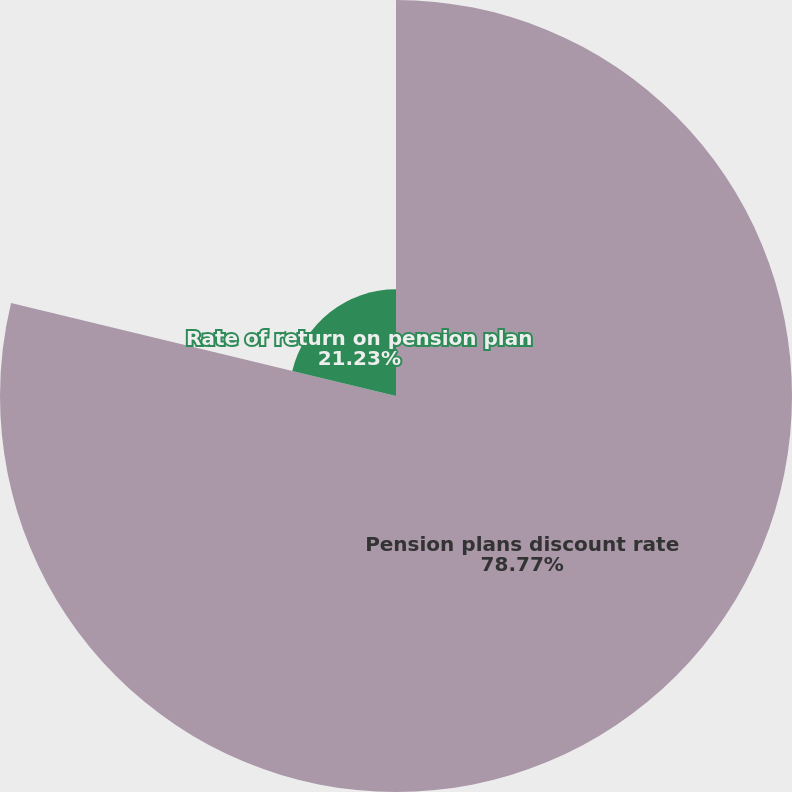Convert chart. <chart><loc_0><loc_0><loc_500><loc_500><pie_chart><fcel>Pension plans discount rate<fcel>Rate of return on pension plan<nl><fcel>78.77%<fcel>21.23%<nl></chart> 